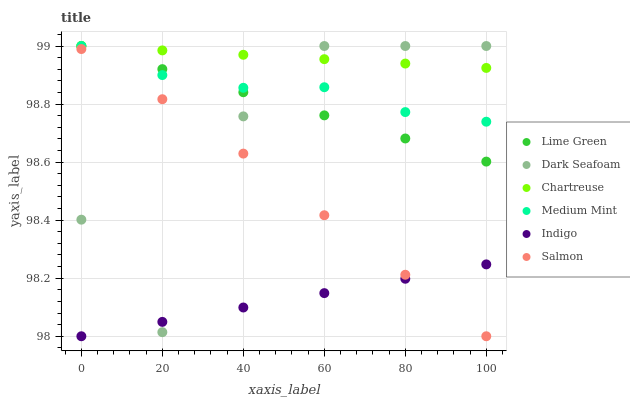Does Indigo have the minimum area under the curve?
Answer yes or no. Yes. Does Chartreuse have the maximum area under the curve?
Answer yes or no. Yes. Does Salmon have the minimum area under the curve?
Answer yes or no. No. Does Salmon have the maximum area under the curve?
Answer yes or no. No. Is Indigo the smoothest?
Answer yes or no. Yes. Is Dark Seafoam the roughest?
Answer yes or no. Yes. Is Salmon the smoothest?
Answer yes or no. No. Is Salmon the roughest?
Answer yes or no. No. Does Indigo have the lowest value?
Answer yes or no. Yes. Does Chartreuse have the lowest value?
Answer yes or no. No. Does Lime Green have the highest value?
Answer yes or no. Yes. Does Salmon have the highest value?
Answer yes or no. No. Is Salmon less than Lime Green?
Answer yes or no. Yes. Is Chartreuse greater than Indigo?
Answer yes or no. Yes. Does Dark Seafoam intersect Chartreuse?
Answer yes or no. Yes. Is Dark Seafoam less than Chartreuse?
Answer yes or no. No. Is Dark Seafoam greater than Chartreuse?
Answer yes or no. No. Does Salmon intersect Lime Green?
Answer yes or no. No. 